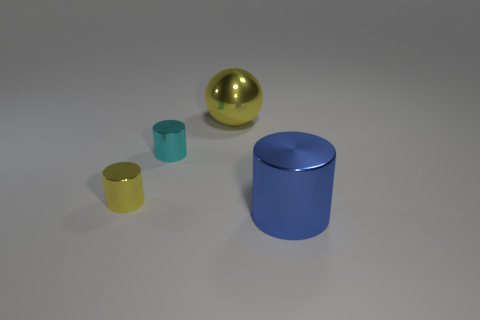What materials do the objects in the image seem to be made of? The objects in the image appear to have different materials. The two cylinders have a matte finish suggesting they could be made of plastic or metal, while the smaller objects, especially the golden sphere, seem to have a reflective surface, possibly indicating a metallic material. 